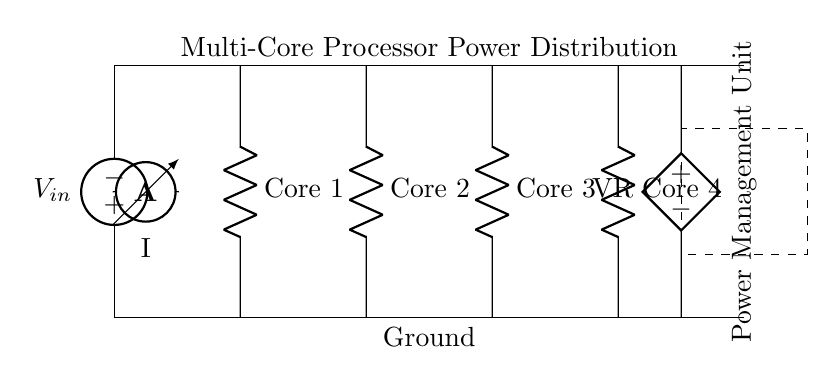What is the voltage supply in this circuit? The circuit shows a voltage source labeled as V_in, which represents the input voltage supply for the parallel circuit.
Answer: V_in How many cores are present in this circuit? There are four components labeled as Core 1, Core 2, Core 3, and Core 4 in the diagram, indicating the presence of four cores.
Answer: Four What is the function of the Power Management Unit? The Power Management Unit is enclosed in a dashed rectangle, indicating it is responsible for regulating and distributing power to the cores effectively.
Answer: Power distribution What kind of circuit is this? The circuit diagram depicts a parallel configuration where each core receives the same voltage from the shared supply.
Answer: Parallel circuit What is connected to the current sensor? The current sensor, labeled as I, is placed between the input voltage and the power distribution line, measuring the current flow entering the circuit.
Answer: Input voltage Which component regulates the voltage in this circuit? The component labeled as VR indicates a voltage regulator that maintains a stable output voltage for the cores despite variations in input voltage or load.
Answer: Voltage regulator What is the orientation of the Power Management Unit? The label for the Power Management Unit is rotated 90 degrees, indicating its vertical orientation on the diagram.
Answer: Vertical 